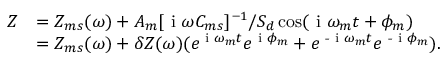Convert formula to latex. <formula><loc_0><loc_0><loc_500><loc_500>\begin{array} { r l } { Z } & { = Z _ { m s } ( \omega ) + A _ { m } [ i \omega C _ { m s } ] ^ { - 1 } / S _ { d } \cos ( i \omega _ { m } t + \phi _ { m } ) } \\ & { = Z _ { m s } ( \omega ) + \delta Z ( \omega ) ( e ^ { i \omega _ { m } t } e ^ { i \phi _ { m } } + e ^ { - i \omega _ { m } t } e ^ { - i \phi _ { m } } ) . } \end{array}</formula> 